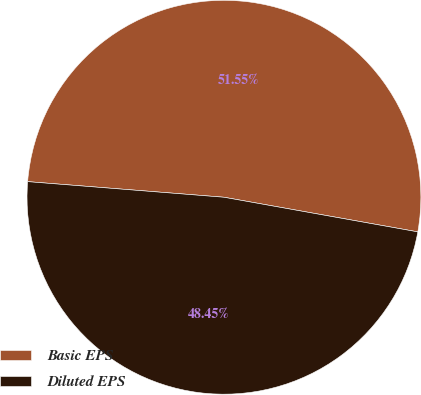Convert chart to OTSL. <chart><loc_0><loc_0><loc_500><loc_500><pie_chart><fcel>Basic EPS<fcel>Diluted EPS<nl><fcel>51.55%<fcel>48.45%<nl></chart> 